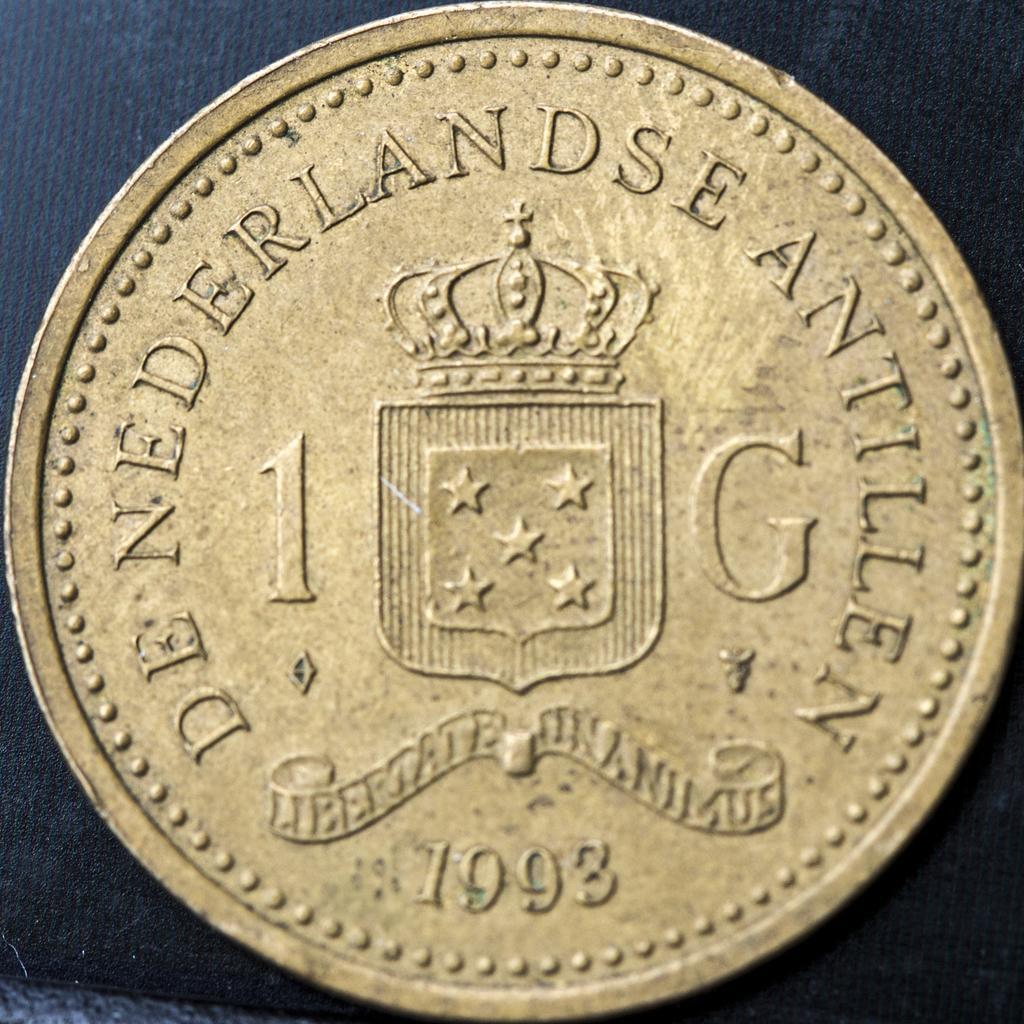<image>
Describe the image concisely. A gold colored coin was minted in 1993. 